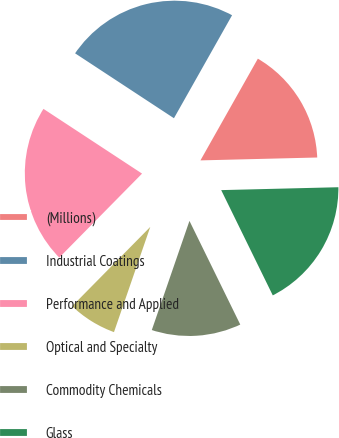Convert chart. <chart><loc_0><loc_0><loc_500><loc_500><pie_chart><fcel>(Millions)<fcel>Industrial Coatings<fcel>Performance and Applied<fcel>Optical and Specialty<fcel>Commodity Chemicals<fcel>Glass<nl><fcel>16.43%<fcel>23.93%<fcel>21.86%<fcel>7.1%<fcel>12.54%<fcel>18.14%<nl></chart> 